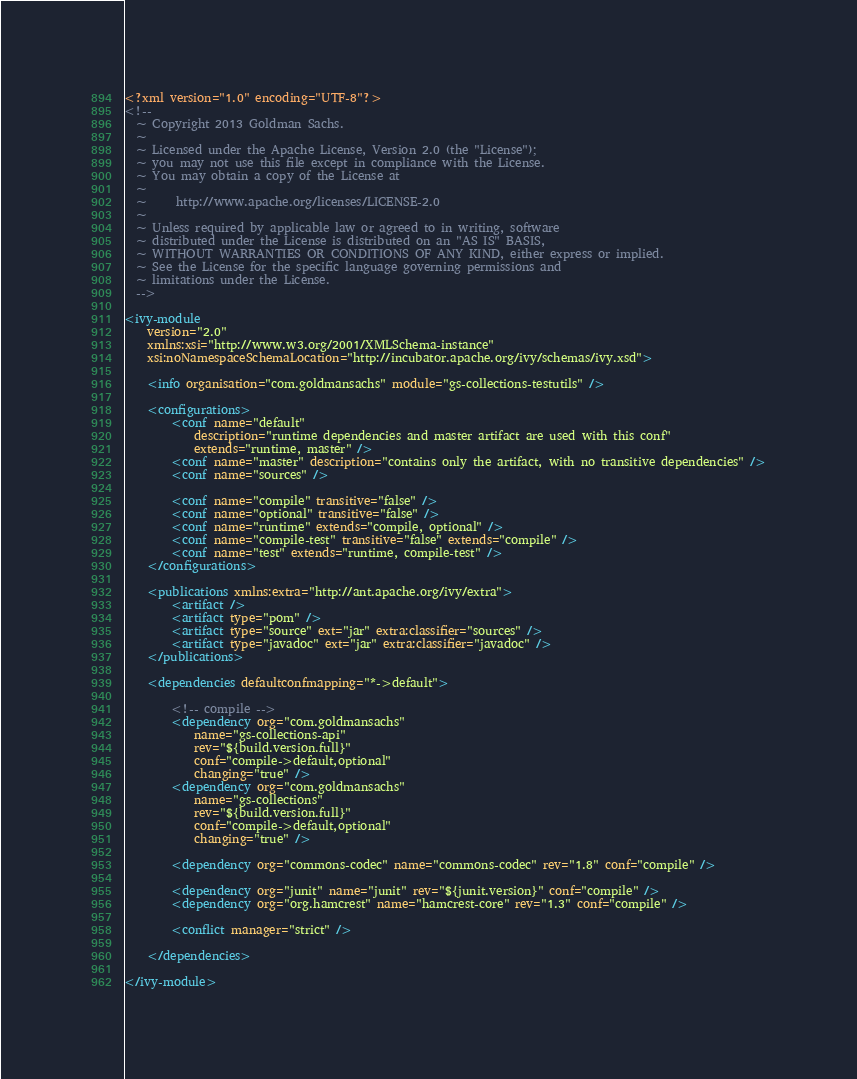Convert code to text. <code><loc_0><loc_0><loc_500><loc_500><_XML_><?xml version="1.0" encoding="UTF-8"?>
<!--
  ~ Copyright 2013 Goldman Sachs.
  ~
  ~ Licensed under the Apache License, Version 2.0 (the "License");
  ~ you may not use this file except in compliance with the License.
  ~ You may obtain a copy of the License at
  ~
  ~     http://www.apache.org/licenses/LICENSE-2.0
  ~
  ~ Unless required by applicable law or agreed to in writing, software
  ~ distributed under the License is distributed on an "AS IS" BASIS,
  ~ WITHOUT WARRANTIES OR CONDITIONS OF ANY KIND, either express or implied.
  ~ See the License for the specific language governing permissions and
  ~ limitations under the License.
  -->

<ivy-module
    version="2.0"
    xmlns:xsi="http://www.w3.org/2001/XMLSchema-instance"
    xsi:noNamespaceSchemaLocation="http://incubator.apache.org/ivy/schemas/ivy.xsd">

    <info organisation="com.goldmansachs" module="gs-collections-testutils" />

    <configurations>
        <conf name="default"
            description="runtime dependencies and master artifact are used with this conf"
            extends="runtime, master" />
        <conf name="master" description="contains only the artifact, with no transitive dependencies" />
        <conf name="sources" />

        <conf name="compile" transitive="false" />
        <conf name="optional" transitive="false" />
        <conf name="runtime" extends="compile, optional" />
        <conf name="compile-test" transitive="false" extends="compile" />
        <conf name="test" extends="runtime, compile-test" />
    </configurations>

    <publications xmlns:extra="http://ant.apache.org/ivy/extra">
        <artifact />
        <artifact type="pom" />
        <artifact type="source" ext="jar" extra:classifier="sources" />
        <artifact type="javadoc" ext="jar" extra:classifier="javadoc" />
    </publications>

    <dependencies defaultconfmapping="*->default">

        <!-- compile -->
        <dependency org="com.goldmansachs"
            name="gs-collections-api"
            rev="${build.version.full}"
            conf="compile->default,optional"
            changing="true" />
        <dependency org="com.goldmansachs"
            name="gs-collections"
            rev="${build.version.full}"
            conf="compile->default,optional"
            changing="true" />

        <dependency org="commons-codec" name="commons-codec" rev="1.8" conf="compile" />

        <dependency org="junit" name="junit" rev="${junit.version}" conf="compile" />
        <dependency org="org.hamcrest" name="hamcrest-core" rev="1.3" conf="compile" />

        <conflict manager="strict" />

    </dependencies>

</ivy-module>
</code> 